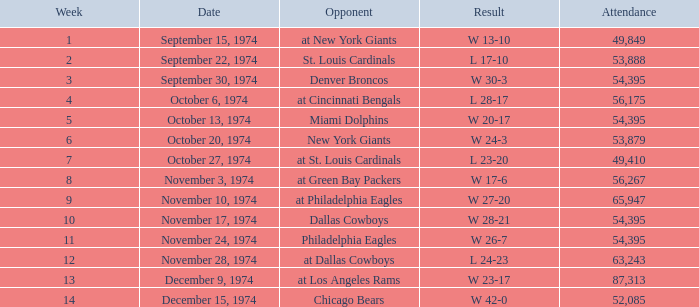What was the result of the game where 63,243 people attended after week 9? W 23-17. 